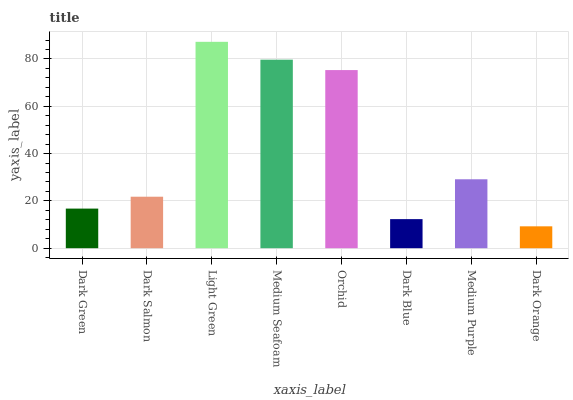Is Dark Orange the minimum?
Answer yes or no. Yes. Is Light Green the maximum?
Answer yes or no. Yes. Is Dark Salmon the minimum?
Answer yes or no. No. Is Dark Salmon the maximum?
Answer yes or no. No. Is Dark Salmon greater than Dark Green?
Answer yes or no. Yes. Is Dark Green less than Dark Salmon?
Answer yes or no. Yes. Is Dark Green greater than Dark Salmon?
Answer yes or no. No. Is Dark Salmon less than Dark Green?
Answer yes or no. No. Is Medium Purple the high median?
Answer yes or no. Yes. Is Dark Salmon the low median?
Answer yes or no. Yes. Is Dark Orange the high median?
Answer yes or no. No. Is Dark Green the low median?
Answer yes or no. No. 